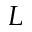Convert formula to latex. <formula><loc_0><loc_0><loc_500><loc_500>L</formula> 